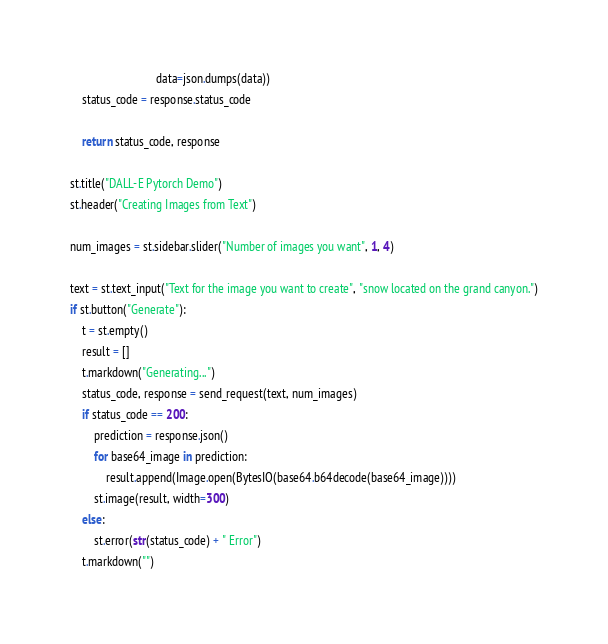<code> <loc_0><loc_0><loc_500><loc_500><_Python_>                             data=json.dumps(data))
    status_code = response.status_code

    return status_code, response

st.title("DALL-E Pytorch Demo")
st.header("Creating Images from Text")

num_images = st.sidebar.slider("Number of images you want", 1, 4)

text = st.text_input("Text for the image you want to create", "snow located on the grand canyon.")
if st.button("Generate"):
    t = st.empty()
    result = []
    t.markdown("Generating...")
    status_code, response = send_request(text, num_images)
    if status_code == 200:
        prediction = response.json()
        for base64_image in prediction:
            result.append(Image.open(BytesIO(base64.b64decode(base64_image))))
        st.image(result, width=300)
    else:
        st.error(str(status_code) + " Error")
    t.markdown("")
</code> 